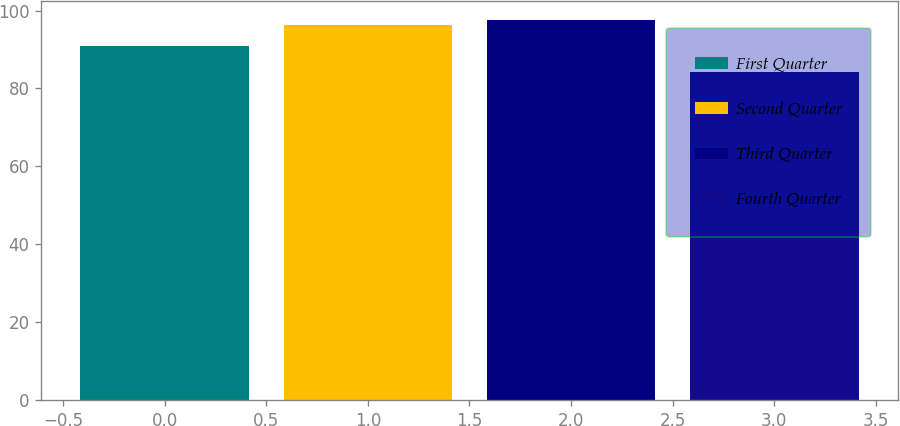Convert chart. <chart><loc_0><loc_0><loc_500><loc_500><bar_chart><fcel>First Quarter<fcel>Second Quarter<fcel>Third Quarter<fcel>Fourth Quarter<nl><fcel>90.83<fcel>96.33<fcel>97.55<fcel>84.19<nl></chart> 